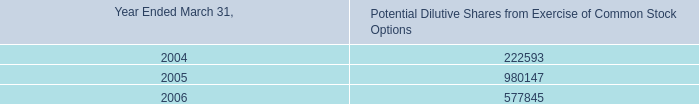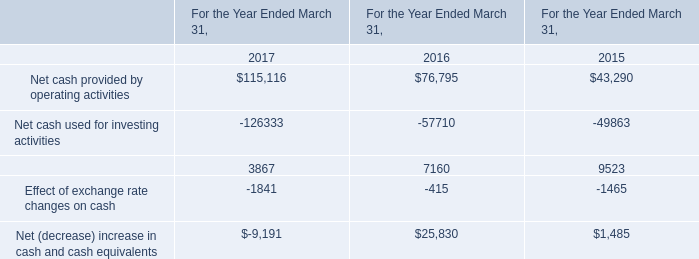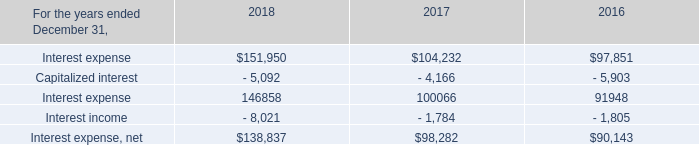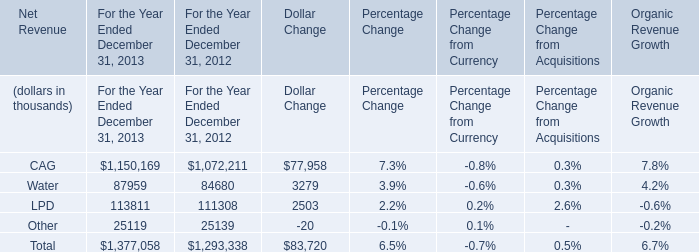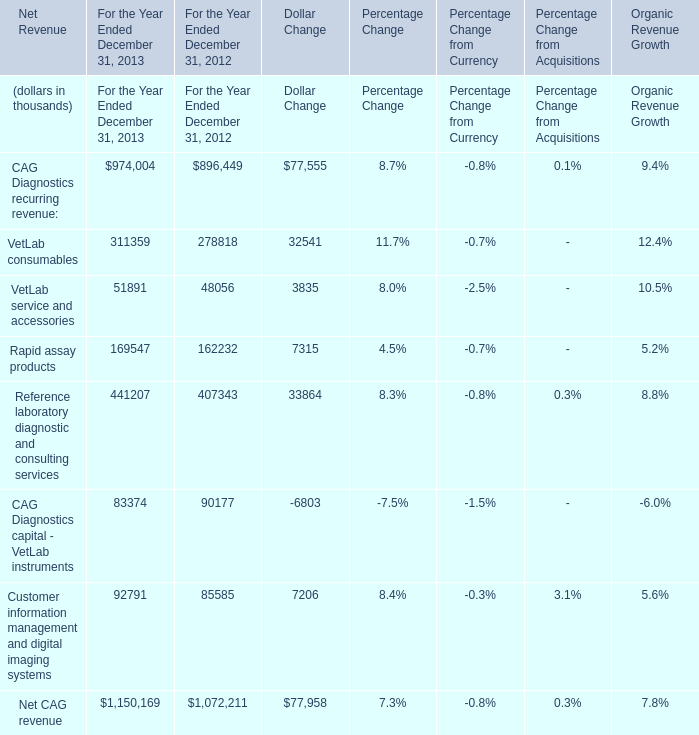What is the sum of For the Year Ended December 31, 2012 in 2012 ? (in thousand) 
Computations: (((((((896449 + 278818) + 48056) + 162232) + 407343) + 90177) + 85585) + 1072211)
Answer: 3040871.0. 